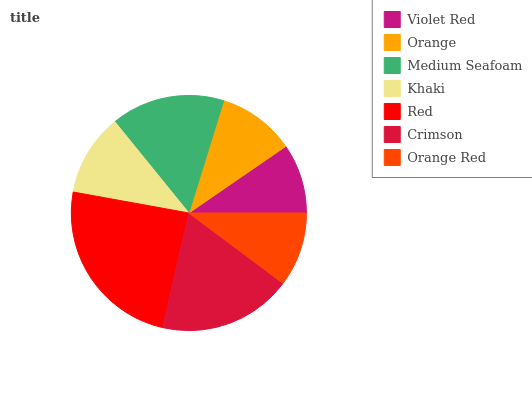Is Violet Red the minimum?
Answer yes or no. Yes. Is Red the maximum?
Answer yes or no. Yes. Is Orange the minimum?
Answer yes or no. No. Is Orange the maximum?
Answer yes or no. No. Is Orange greater than Violet Red?
Answer yes or no. Yes. Is Violet Red less than Orange?
Answer yes or no. Yes. Is Violet Red greater than Orange?
Answer yes or no. No. Is Orange less than Violet Red?
Answer yes or no. No. Is Khaki the high median?
Answer yes or no. Yes. Is Khaki the low median?
Answer yes or no. Yes. Is Medium Seafoam the high median?
Answer yes or no. No. Is Crimson the low median?
Answer yes or no. No. 